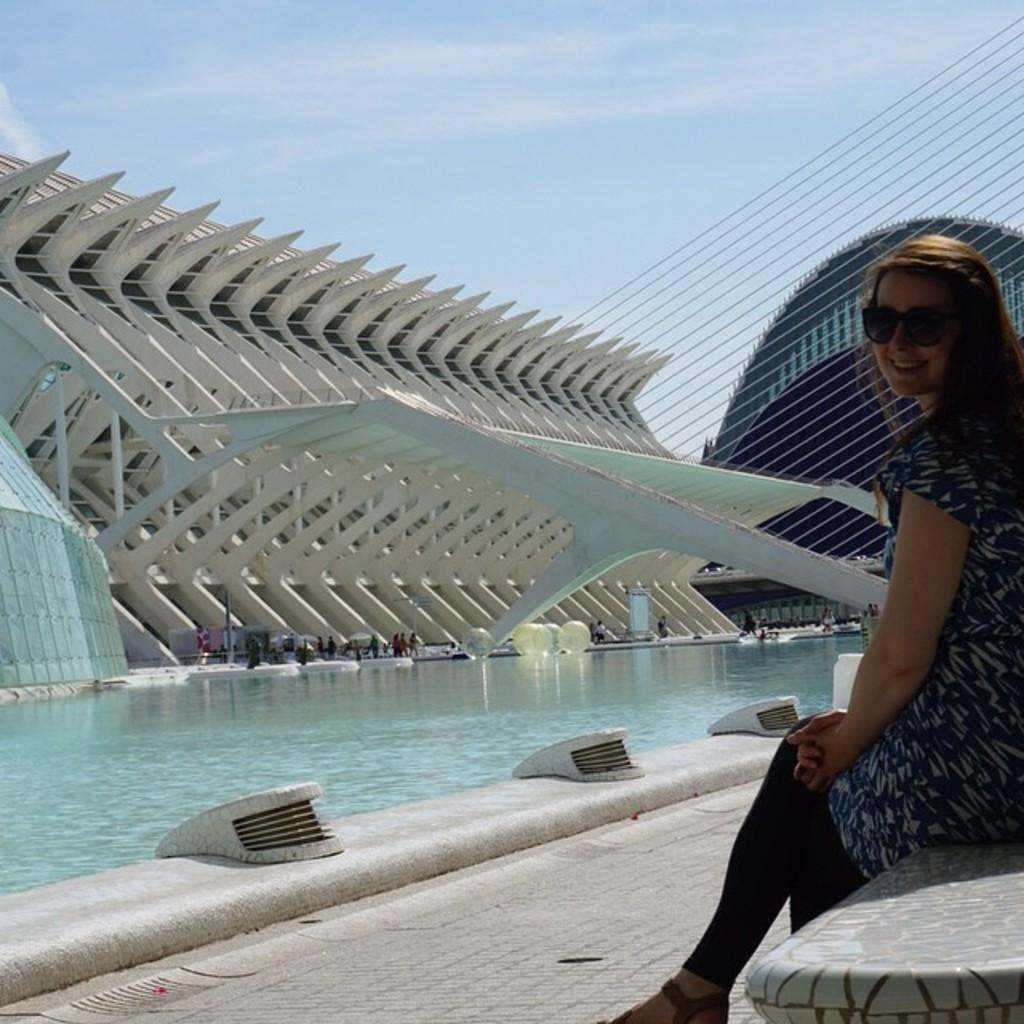Who is the main subject in the image? There is a woman in the image. What is the woman wearing? The woman is wearing a black and white dress. Where is the woman sitting? The woman is sitting on a bench. What can be seen in the background of the image? There is a swimming pool, people, buildings, and the sky visible in the background of the image. What type of mailbox can be seen near the woman in the image? There is no mailbox present in the image. How does the woman's hair look in the image? The provided facts do not mention the woman's hair, so we cannot answer this question. 